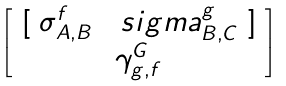<formula> <loc_0><loc_0><loc_500><loc_500>\begin{bmatrix} \ [ \ \sigma ^ { f } _ { A , B } \quad s i g m a ^ { g } _ { B , C } \ ] \ \\ \gamma ^ { G } _ { g , f } \end{bmatrix}</formula> 